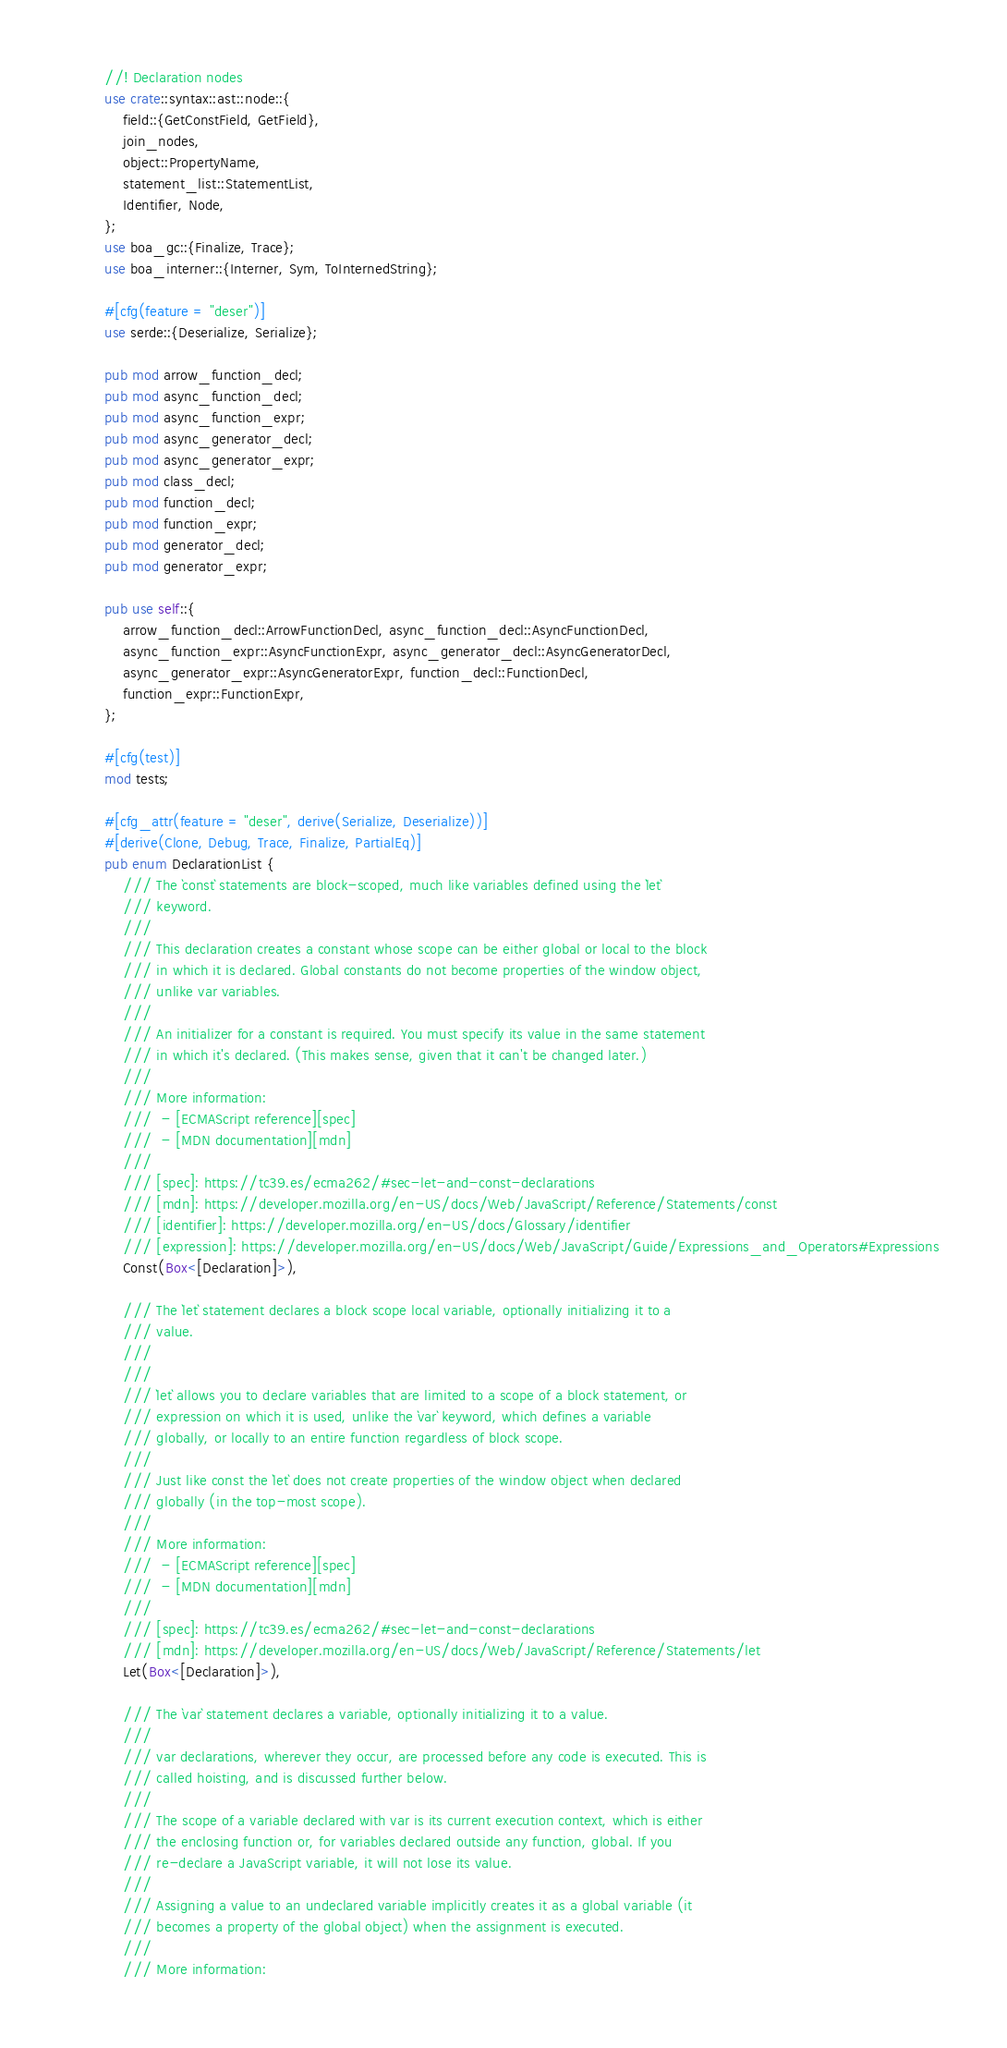Convert code to text. <code><loc_0><loc_0><loc_500><loc_500><_Rust_>//! Declaration nodes
use crate::syntax::ast::node::{
    field::{GetConstField, GetField},
    join_nodes,
    object::PropertyName,
    statement_list::StatementList,
    Identifier, Node,
};
use boa_gc::{Finalize, Trace};
use boa_interner::{Interner, Sym, ToInternedString};

#[cfg(feature = "deser")]
use serde::{Deserialize, Serialize};

pub mod arrow_function_decl;
pub mod async_function_decl;
pub mod async_function_expr;
pub mod async_generator_decl;
pub mod async_generator_expr;
pub mod class_decl;
pub mod function_decl;
pub mod function_expr;
pub mod generator_decl;
pub mod generator_expr;

pub use self::{
    arrow_function_decl::ArrowFunctionDecl, async_function_decl::AsyncFunctionDecl,
    async_function_expr::AsyncFunctionExpr, async_generator_decl::AsyncGeneratorDecl,
    async_generator_expr::AsyncGeneratorExpr, function_decl::FunctionDecl,
    function_expr::FunctionExpr,
};

#[cfg(test)]
mod tests;

#[cfg_attr(feature = "deser", derive(Serialize, Deserialize))]
#[derive(Clone, Debug, Trace, Finalize, PartialEq)]
pub enum DeclarationList {
    /// The `const` statements are block-scoped, much like variables defined using the `let`
    /// keyword.
    ///
    /// This declaration creates a constant whose scope can be either global or local to the block
    /// in which it is declared. Global constants do not become properties of the window object,
    /// unlike var variables.
    ///
    /// An initializer for a constant is required. You must specify its value in the same statement
    /// in which it's declared. (This makes sense, given that it can't be changed later.)
    ///
    /// More information:
    ///  - [ECMAScript reference][spec]
    ///  - [MDN documentation][mdn]
    ///
    /// [spec]: https://tc39.es/ecma262/#sec-let-and-const-declarations
    /// [mdn]: https://developer.mozilla.org/en-US/docs/Web/JavaScript/Reference/Statements/const
    /// [identifier]: https://developer.mozilla.org/en-US/docs/Glossary/identifier
    /// [expression]: https://developer.mozilla.org/en-US/docs/Web/JavaScript/Guide/Expressions_and_Operators#Expressions
    Const(Box<[Declaration]>),

    /// The `let` statement declares a block scope local variable, optionally initializing it to a
    /// value.
    ///
    ///
    /// `let` allows you to declare variables that are limited to a scope of a block statement, or
    /// expression on which it is used, unlike the `var` keyword, which defines a variable
    /// globally, or locally to an entire function regardless of block scope.
    ///
    /// Just like const the `let` does not create properties of the window object when declared
    /// globally (in the top-most scope).
    ///
    /// More information:
    ///  - [ECMAScript reference][spec]
    ///  - [MDN documentation][mdn]
    ///
    /// [spec]: https://tc39.es/ecma262/#sec-let-and-const-declarations
    /// [mdn]: https://developer.mozilla.org/en-US/docs/Web/JavaScript/Reference/Statements/let
    Let(Box<[Declaration]>),

    /// The `var` statement declares a variable, optionally initializing it to a value.
    ///
    /// var declarations, wherever they occur, are processed before any code is executed. This is
    /// called hoisting, and is discussed further below.
    ///
    /// The scope of a variable declared with var is its current execution context, which is either
    /// the enclosing function or, for variables declared outside any function, global. If you
    /// re-declare a JavaScript variable, it will not lose its value.
    ///
    /// Assigning a value to an undeclared variable implicitly creates it as a global variable (it
    /// becomes a property of the global object) when the assignment is executed.
    ///
    /// More information:</code> 